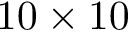Convert formula to latex. <formula><loc_0><loc_0><loc_500><loc_500>1 0 \times 1 0</formula> 